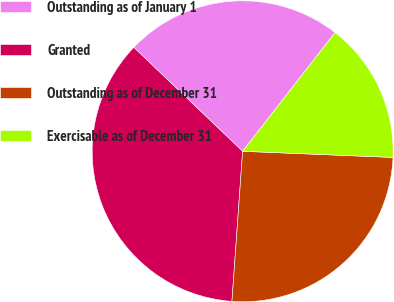<chart> <loc_0><loc_0><loc_500><loc_500><pie_chart><fcel>Outstanding as of January 1<fcel>Granted<fcel>Outstanding as of December 31<fcel>Exercisable as of December 31<nl><fcel>23.4%<fcel>36.0%<fcel>25.48%<fcel>15.12%<nl></chart> 